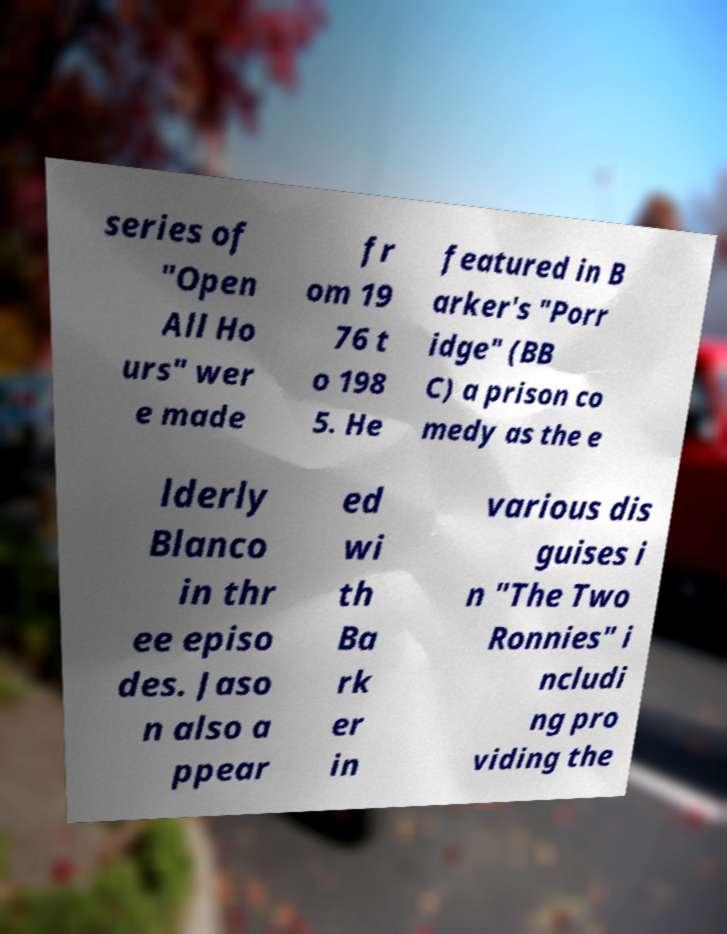There's text embedded in this image that I need extracted. Can you transcribe it verbatim? series of "Open All Ho urs" wer e made fr om 19 76 t o 198 5. He featured in B arker's "Porr idge" (BB C) a prison co medy as the e lderly Blanco in thr ee episo des. Jaso n also a ppear ed wi th Ba rk er in various dis guises i n "The Two Ronnies" i ncludi ng pro viding the 